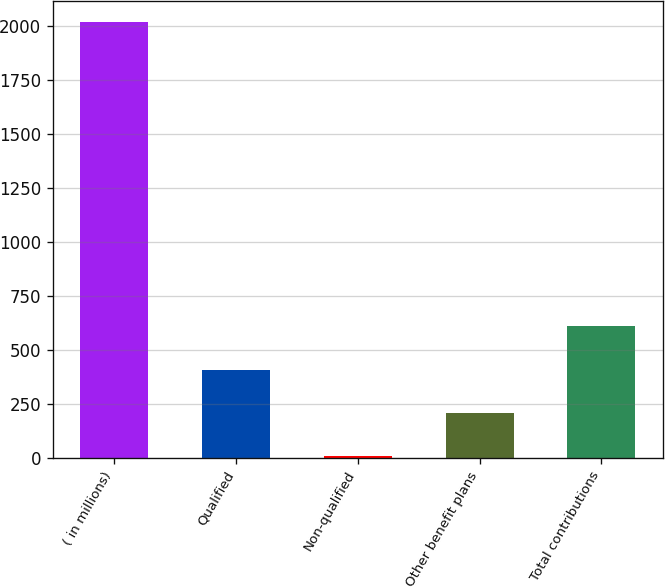<chart> <loc_0><loc_0><loc_500><loc_500><bar_chart><fcel>( in millions)<fcel>Qualified<fcel>Non-qualified<fcel>Other benefit plans<fcel>Total contributions<nl><fcel>2016<fcel>408<fcel>6<fcel>207<fcel>609<nl></chart> 